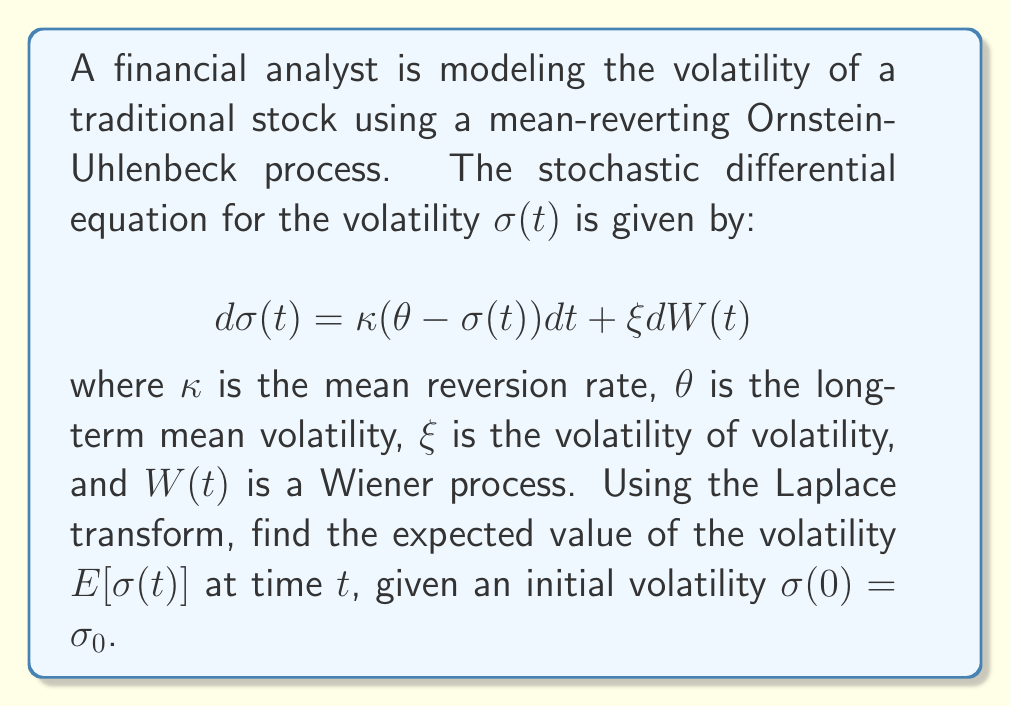Provide a solution to this math problem. To solve this problem, we'll use the Laplace transform technique:

1) First, we take the expectation of both sides of the SDE:

   $$E[d\sigma(t)] = \kappa(\theta - E[\sigma(t)])dt$$

2) Let $m(t) = E[\sigma(t)]$. Then we have:

   $$\frac{dm(t)}{dt} = \kappa(\theta - m(t))$$

3) This is a first-order linear differential equation. We'll solve it using the Laplace transform. Let $M(s)$ be the Laplace transform of $m(t)$. Taking the Laplace transform of both sides:

   $$sM(s) - m(0) = \kappa\theta\frac{1}{s} - \kappa M(s)$$

   where $m(0) = \sigma_0$ (the initial condition).

4) Rearranging terms:

   $$(s + \kappa)M(s) = \sigma_0 + \frac{\kappa\theta}{s}$$

5) Solving for $M(s)$:

   $$M(s) = \frac{\sigma_0}{s + \kappa} + \frac{\kappa\theta}{s(s + \kappa)}$$

6) This can be rewritten as:

   $$M(s) = \frac{\sigma_0}{s + \kappa} + \frac{\theta}{s} - \frac{\theta}{s + \kappa}$$

7) Taking the inverse Laplace transform:

   $$m(t) = \sigma_0e^{-\kappa t} + \theta(1 - e^{-\kappa t})$$

8) Therefore, the expected value of the volatility at time $t$ is:

   $$E[\sigma(t)] = \sigma_0e^{-\kappa t} + \theta(1 - e^{-\kappa t})$$

This result shows that the expected volatility starts at $\sigma_0$ and exponentially approaches the long-term mean $\theta$ as $t$ increases.
Answer: $E[\sigma(t)] = \sigma_0e^{-\kappa t} + \theta(1 - e^{-\kappa t})$ 